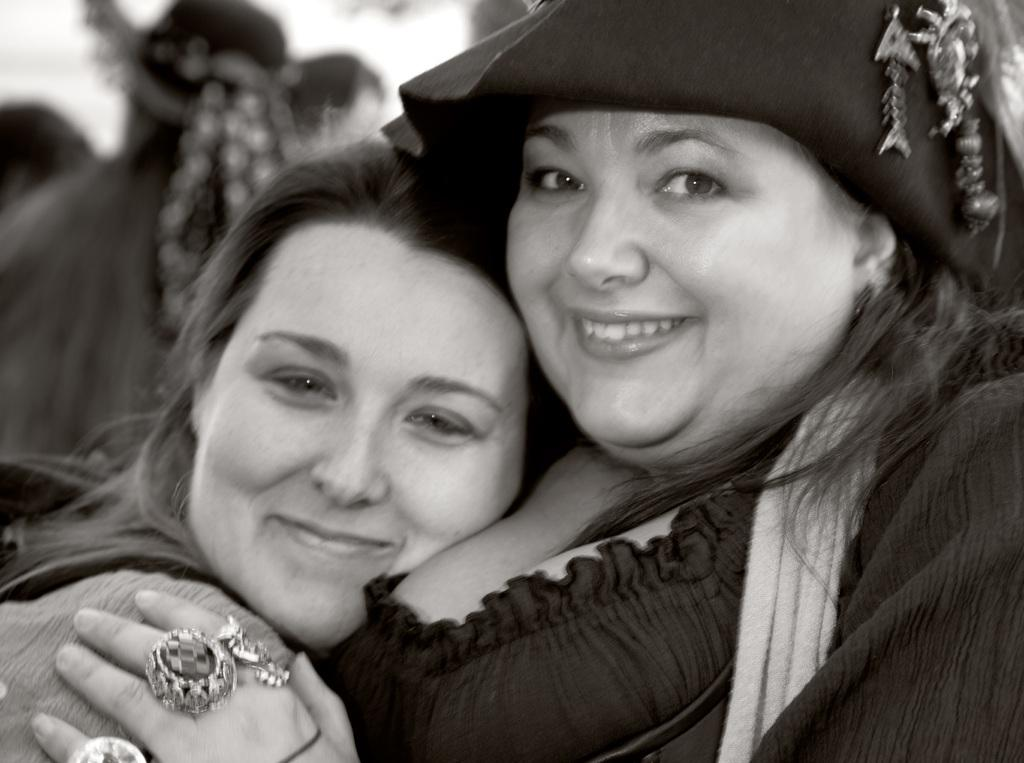Who or what can be seen in the image? There are people in the image. What is the facial expression of the people in the image? The people have smiling faces. What is the value of the watch worn by the person in the image? There is no watch present in the image, so it is not possible to determine its value. 